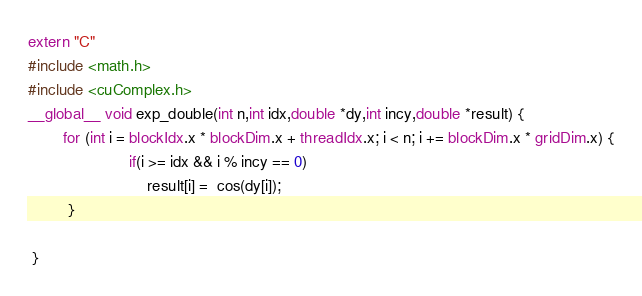<code> <loc_0><loc_0><loc_500><loc_500><_Cuda_>extern "C"
#include <math.h>
#include <cuComplex.h>
__global__ void exp_double(int n,int idx,double *dy,int incy,double *result) {
        for (int i = blockIdx.x * blockDim.x + threadIdx.x; i < n; i += blockDim.x * gridDim.x) {
                       if(i >= idx && i % incy == 0)
                           result[i] =  cos(dy[i]);
         }

 }</code> 